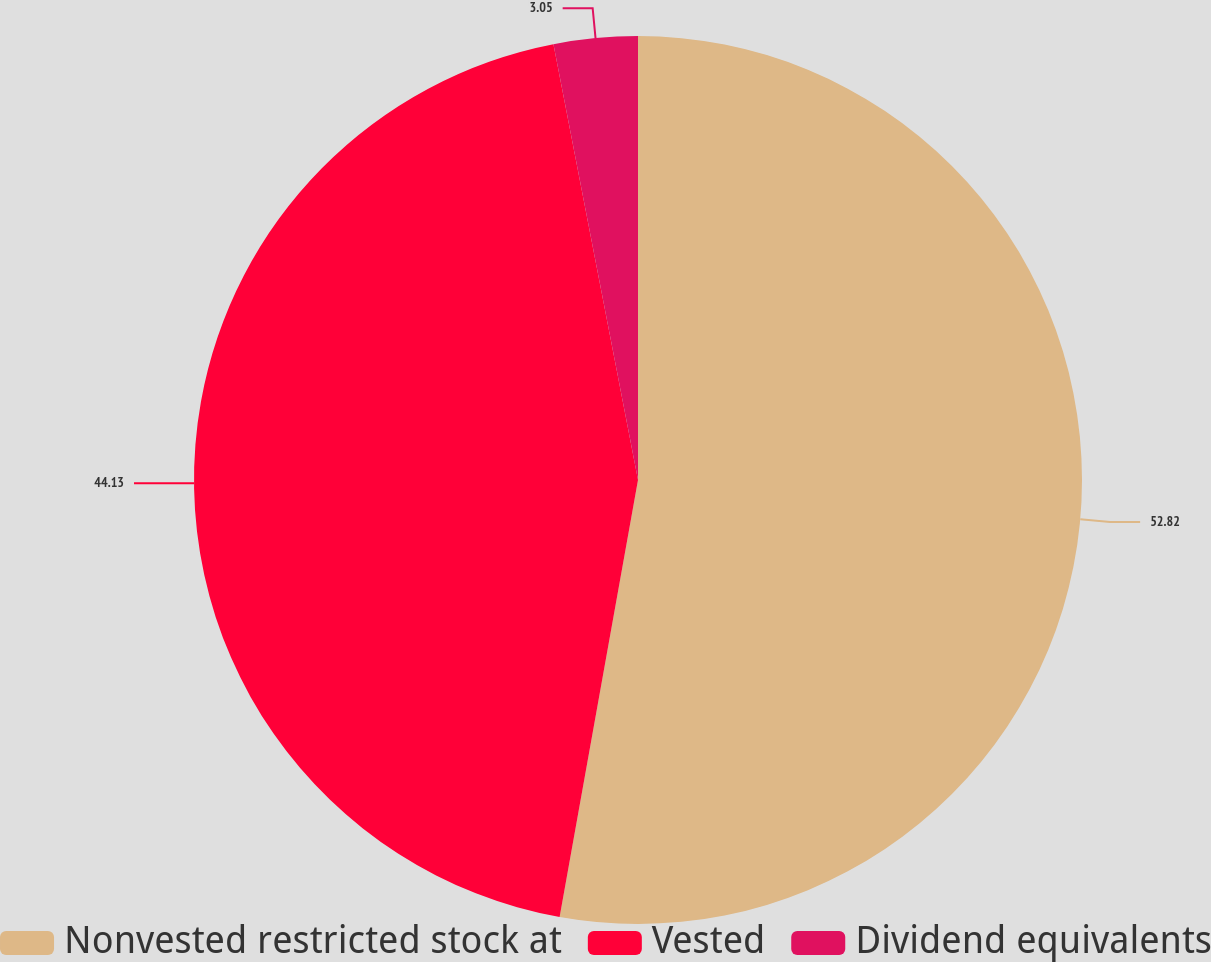Convert chart to OTSL. <chart><loc_0><loc_0><loc_500><loc_500><pie_chart><fcel>Nonvested restricted stock at<fcel>Vested<fcel>Dividend equivalents<nl><fcel>52.83%<fcel>44.13%<fcel>3.05%<nl></chart> 